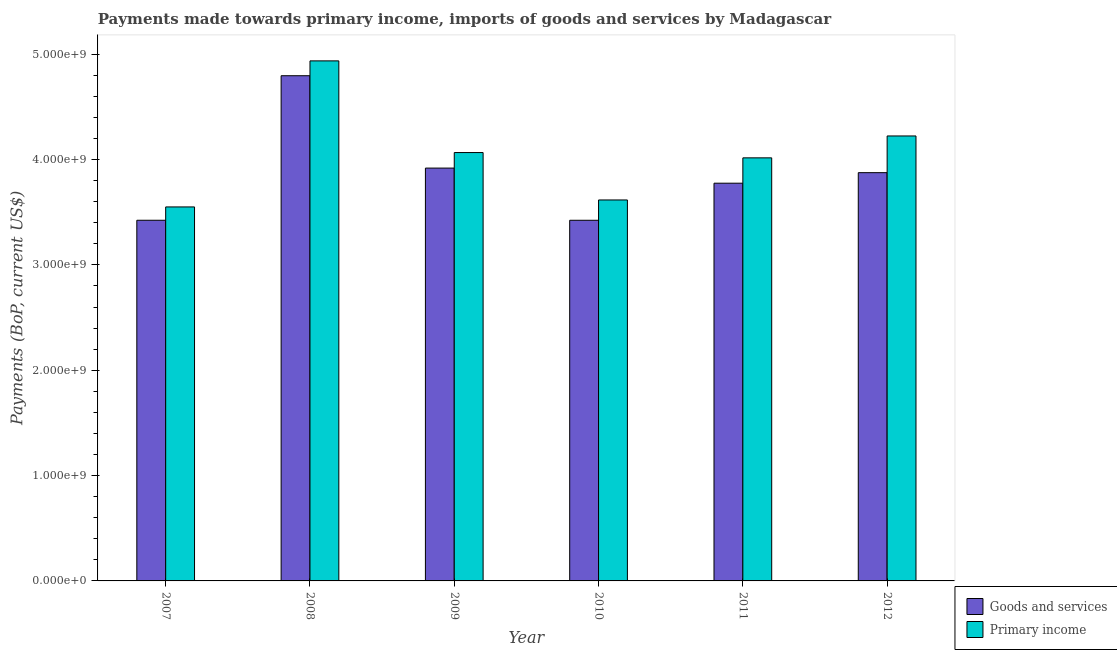How many different coloured bars are there?
Make the answer very short. 2. Are the number of bars per tick equal to the number of legend labels?
Keep it short and to the point. Yes. How many bars are there on the 5th tick from the left?
Offer a terse response. 2. What is the label of the 4th group of bars from the left?
Keep it short and to the point. 2010. In how many cases, is the number of bars for a given year not equal to the number of legend labels?
Make the answer very short. 0. What is the payments made towards primary income in 2011?
Make the answer very short. 4.02e+09. Across all years, what is the maximum payments made towards primary income?
Provide a succinct answer. 4.94e+09. Across all years, what is the minimum payments made towards primary income?
Make the answer very short. 3.55e+09. In which year was the payments made towards goods and services maximum?
Your answer should be very brief. 2008. In which year was the payments made towards primary income minimum?
Your answer should be compact. 2007. What is the total payments made towards primary income in the graph?
Ensure brevity in your answer.  2.44e+1. What is the difference between the payments made towards goods and services in 2007 and that in 2009?
Offer a very short reply. -4.95e+08. What is the difference between the payments made towards goods and services in 2009 and the payments made towards primary income in 2010?
Provide a succinct answer. 4.95e+08. What is the average payments made towards goods and services per year?
Offer a terse response. 3.87e+09. In the year 2011, what is the difference between the payments made towards primary income and payments made towards goods and services?
Your response must be concise. 0. What is the ratio of the payments made towards goods and services in 2009 to that in 2011?
Provide a succinct answer. 1.04. Is the payments made towards primary income in 2008 less than that in 2012?
Your answer should be compact. No. What is the difference between the highest and the second highest payments made towards primary income?
Make the answer very short. 7.13e+08. What is the difference between the highest and the lowest payments made towards goods and services?
Make the answer very short. 1.37e+09. In how many years, is the payments made towards primary income greater than the average payments made towards primary income taken over all years?
Give a very brief answer. 2. Is the sum of the payments made towards goods and services in 2007 and 2011 greater than the maximum payments made towards primary income across all years?
Ensure brevity in your answer.  Yes. What does the 2nd bar from the left in 2012 represents?
Provide a short and direct response. Primary income. What does the 2nd bar from the right in 2007 represents?
Ensure brevity in your answer.  Goods and services. How many bars are there?
Offer a terse response. 12. Are all the bars in the graph horizontal?
Offer a very short reply. No. Does the graph contain any zero values?
Make the answer very short. No. How are the legend labels stacked?
Provide a succinct answer. Vertical. What is the title of the graph?
Ensure brevity in your answer.  Payments made towards primary income, imports of goods and services by Madagascar. Does "Canada" appear as one of the legend labels in the graph?
Offer a very short reply. No. What is the label or title of the X-axis?
Offer a terse response. Year. What is the label or title of the Y-axis?
Your answer should be very brief. Payments (BoP, current US$). What is the Payments (BoP, current US$) of Goods and services in 2007?
Keep it short and to the point. 3.42e+09. What is the Payments (BoP, current US$) of Primary income in 2007?
Ensure brevity in your answer.  3.55e+09. What is the Payments (BoP, current US$) of Goods and services in 2008?
Offer a terse response. 4.80e+09. What is the Payments (BoP, current US$) of Primary income in 2008?
Ensure brevity in your answer.  4.94e+09. What is the Payments (BoP, current US$) in Goods and services in 2009?
Keep it short and to the point. 3.92e+09. What is the Payments (BoP, current US$) of Primary income in 2009?
Give a very brief answer. 4.07e+09. What is the Payments (BoP, current US$) of Goods and services in 2010?
Your answer should be compact. 3.42e+09. What is the Payments (BoP, current US$) of Primary income in 2010?
Offer a very short reply. 3.62e+09. What is the Payments (BoP, current US$) of Goods and services in 2011?
Provide a short and direct response. 3.78e+09. What is the Payments (BoP, current US$) of Primary income in 2011?
Make the answer very short. 4.02e+09. What is the Payments (BoP, current US$) in Goods and services in 2012?
Give a very brief answer. 3.88e+09. What is the Payments (BoP, current US$) in Primary income in 2012?
Give a very brief answer. 4.22e+09. Across all years, what is the maximum Payments (BoP, current US$) in Goods and services?
Give a very brief answer. 4.80e+09. Across all years, what is the maximum Payments (BoP, current US$) of Primary income?
Ensure brevity in your answer.  4.94e+09. Across all years, what is the minimum Payments (BoP, current US$) of Goods and services?
Keep it short and to the point. 3.42e+09. Across all years, what is the minimum Payments (BoP, current US$) of Primary income?
Provide a short and direct response. 3.55e+09. What is the total Payments (BoP, current US$) of Goods and services in the graph?
Ensure brevity in your answer.  2.32e+1. What is the total Payments (BoP, current US$) of Primary income in the graph?
Your response must be concise. 2.44e+1. What is the difference between the Payments (BoP, current US$) of Goods and services in 2007 and that in 2008?
Keep it short and to the point. -1.37e+09. What is the difference between the Payments (BoP, current US$) of Primary income in 2007 and that in 2008?
Your response must be concise. -1.39e+09. What is the difference between the Payments (BoP, current US$) of Goods and services in 2007 and that in 2009?
Give a very brief answer. -4.95e+08. What is the difference between the Payments (BoP, current US$) of Primary income in 2007 and that in 2009?
Provide a short and direct response. -5.16e+08. What is the difference between the Payments (BoP, current US$) of Goods and services in 2007 and that in 2010?
Your answer should be very brief. 1.95e+05. What is the difference between the Payments (BoP, current US$) in Primary income in 2007 and that in 2010?
Ensure brevity in your answer.  -6.61e+07. What is the difference between the Payments (BoP, current US$) of Goods and services in 2007 and that in 2011?
Provide a succinct answer. -3.52e+08. What is the difference between the Payments (BoP, current US$) of Primary income in 2007 and that in 2011?
Provide a succinct answer. -4.66e+08. What is the difference between the Payments (BoP, current US$) of Goods and services in 2007 and that in 2012?
Provide a succinct answer. -4.52e+08. What is the difference between the Payments (BoP, current US$) in Primary income in 2007 and that in 2012?
Your answer should be very brief. -6.74e+08. What is the difference between the Payments (BoP, current US$) of Goods and services in 2008 and that in 2009?
Your response must be concise. 8.77e+08. What is the difference between the Payments (BoP, current US$) of Primary income in 2008 and that in 2009?
Ensure brevity in your answer.  8.70e+08. What is the difference between the Payments (BoP, current US$) in Goods and services in 2008 and that in 2010?
Your response must be concise. 1.37e+09. What is the difference between the Payments (BoP, current US$) in Primary income in 2008 and that in 2010?
Offer a very short reply. 1.32e+09. What is the difference between the Payments (BoP, current US$) of Goods and services in 2008 and that in 2011?
Give a very brief answer. 1.02e+09. What is the difference between the Payments (BoP, current US$) of Primary income in 2008 and that in 2011?
Offer a very short reply. 9.20e+08. What is the difference between the Payments (BoP, current US$) in Goods and services in 2008 and that in 2012?
Your response must be concise. 9.20e+08. What is the difference between the Payments (BoP, current US$) of Primary income in 2008 and that in 2012?
Offer a very short reply. 7.13e+08. What is the difference between the Payments (BoP, current US$) in Goods and services in 2009 and that in 2010?
Your response must be concise. 4.95e+08. What is the difference between the Payments (BoP, current US$) of Primary income in 2009 and that in 2010?
Offer a terse response. 4.50e+08. What is the difference between the Payments (BoP, current US$) in Goods and services in 2009 and that in 2011?
Your answer should be very brief. 1.43e+08. What is the difference between the Payments (BoP, current US$) of Primary income in 2009 and that in 2011?
Keep it short and to the point. 5.02e+07. What is the difference between the Payments (BoP, current US$) of Goods and services in 2009 and that in 2012?
Offer a terse response. 4.34e+07. What is the difference between the Payments (BoP, current US$) in Primary income in 2009 and that in 2012?
Your answer should be very brief. -1.58e+08. What is the difference between the Payments (BoP, current US$) of Goods and services in 2010 and that in 2011?
Give a very brief answer. -3.52e+08. What is the difference between the Payments (BoP, current US$) in Primary income in 2010 and that in 2011?
Your response must be concise. -4.00e+08. What is the difference between the Payments (BoP, current US$) in Goods and services in 2010 and that in 2012?
Ensure brevity in your answer.  -4.52e+08. What is the difference between the Payments (BoP, current US$) in Primary income in 2010 and that in 2012?
Make the answer very short. -6.08e+08. What is the difference between the Payments (BoP, current US$) in Goods and services in 2011 and that in 2012?
Make the answer very short. -1.00e+08. What is the difference between the Payments (BoP, current US$) in Primary income in 2011 and that in 2012?
Offer a terse response. -2.08e+08. What is the difference between the Payments (BoP, current US$) of Goods and services in 2007 and the Payments (BoP, current US$) of Primary income in 2008?
Your answer should be compact. -1.51e+09. What is the difference between the Payments (BoP, current US$) of Goods and services in 2007 and the Payments (BoP, current US$) of Primary income in 2009?
Provide a short and direct response. -6.43e+08. What is the difference between the Payments (BoP, current US$) of Goods and services in 2007 and the Payments (BoP, current US$) of Primary income in 2010?
Keep it short and to the point. -1.93e+08. What is the difference between the Payments (BoP, current US$) of Goods and services in 2007 and the Payments (BoP, current US$) of Primary income in 2011?
Provide a short and direct response. -5.92e+08. What is the difference between the Payments (BoP, current US$) in Goods and services in 2007 and the Payments (BoP, current US$) in Primary income in 2012?
Provide a succinct answer. -8.00e+08. What is the difference between the Payments (BoP, current US$) of Goods and services in 2008 and the Payments (BoP, current US$) of Primary income in 2009?
Your answer should be very brief. 7.29e+08. What is the difference between the Payments (BoP, current US$) in Goods and services in 2008 and the Payments (BoP, current US$) in Primary income in 2010?
Make the answer very short. 1.18e+09. What is the difference between the Payments (BoP, current US$) in Goods and services in 2008 and the Payments (BoP, current US$) in Primary income in 2011?
Provide a short and direct response. 7.79e+08. What is the difference between the Payments (BoP, current US$) in Goods and services in 2008 and the Payments (BoP, current US$) in Primary income in 2012?
Offer a very short reply. 5.72e+08. What is the difference between the Payments (BoP, current US$) in Goods and services in 2009 and the Payments (BoP, current US$) in Primary income in 2010?
Your response must be concise. 3.03e+08. What is the difference between the Payments (BoP, current US$) of Goods and services in 2009 and the Payments (BoP, current US$) of Primary income in 2011?
Ensure brevity in your answer.  -9.72e+07. What is the difference between the Payments (BoP, current US$) in Goods and services in 2009 and the Payments (BoP, current US$) in Primary income in 2012?
Your response must be concise. -3.05e+08. What is the difference between the Payments (BoP, current US$) of Goods and services in 2010 and the Payments (BoP, current US$) of Primary income in 2011?
Make the answer very short. -5.92e+08. What is the difference between the Payments (BoP, current US$) in Goods and services in 2010 and the Payments (BoP, current US$) in Primary income in 2012?
Provide a succinct answer. -8.00e+08. What is the difference between the Payments (BoP, current US$) of Goods and services in 2011 and the Payments (BoP, current US$) of Primary income in 2012?
Provide a succinct answer. -4.48e+08. What is the average Payments (BoP, current US$) in Goods and services per year?
Provide a short and direct response. 3.87e+09. What is the average Payments (BoP, current US$) of Primary income per year?
Offer a very short reply. 4.07e+09. In the year 2007, what is the difference between the Payments (BoP, current US$) in Goods and services and Payments (BoP, current US$) in Primary income?
Provide a succinct answer. -1.26e+08. In the year 2008, what is the difference between the Payments (BoP, current US$) in Goods and services and Payments (BoP, current US$) in Primary income?
Offer a very short reply. -1.41e+08. In the year 2009, what is the difference between the Payments (BoP, current US$) in Goods and services and Payments (BoP, current US$) in Primary income?
Ensure brevity in your answer.  -1.47e+08. In the year 2010, what is the difference between the Payments (BoP, current US$) in Goods and services and Payments (BoP, current US$) in Primary income?
Provide a succinct answer. -1.93e+08. In the year 2011, what is the difference between the Payments (BoP, current US$) in Goods and services and Payments (BoP, current US$) in Primary income?
Provide a short and direct response. -2.41e+08. In the year 2012, what is the difference between the Payments (BoP, current US$) of Goods and services and Payments (BoP, current US$) of Primary income?
Keep it short and to the point. -3.48e+08. What is the ratio of the Payments (BoP, current US$) of Goods and services in 2007 to that in 2008?
Your answer should be very brief. 0.71. What is the ratio of the Payments (BoP, current US$) of Primary income in 2007 to that in 2008?
Your answer should be compact. 0.72. What is the ratio of the Payments (BoP, current US$) in Goods and services in 2007 to that in 2009?
Offer a terse response. 0.87. What is the ratio of the Payments (BoP, current US$) of Primary income in 2007 to that in 2009?
Provide a short and direct response. 0.87. What is the ratio of the Payments (BoP, current US$) in Primary income in 2007 to that in 2010?
Ensure brevity in your answer.  0.98. What is the ratio of the Payments (BoP, current US$) of Goods and services in 2007 to that in 2011?
Give a very brief answer. 0.91. What is the ratio of the Payments (BoP, current US$) of Primary income in 2007 to that in 2011?
Your answer should be very brief. 0.88. What is the ratio of the Payments (BoP, current US$) in Goods and services in 2007 to that in 2012?
Give a very brief answer. 0.88. What is the ratio of the Payments (BoP, current US$) in Primary income in 2007 to that in 2012?
Your answer should be compact. 0.84. What is the ratio of the Payments (BoP, current US$) in Goods and services in 2008 to that in 2009?
Give a very brief answer. 1.22. What is the ratio of the Payments (BoP, current US$) in Primary income in 2008 to that in 2009?
Provide a succinct answer. 1.21. What is the ratio of the Payments (BoP, current US$) of Goods and services in 2008 to that in 2010?
Your response must be concise. 1.4. What is the ratio of the Payments (BoP, current US$) of Primary income in 2008 to that in 2010?
Your response must be concise. 1.37. What is the ratio of the Payments (BoP, current US$) in Goods and services in 2008 to that in 2011?
Offer a very short reply. 1.27. What is the ratio of the Payments (BoP, current US$) of Primary income in 2008 to that in 2011?
Offer a very short reply. 1.23. What is the ratio of the Payments (BoP, current US$) in Goods and services in 2008 to that in 2012?
Give a very brief answer. 1.24. What is the ratio of the Payments (BoP, current US$) of Primary income in 2008 to that in 2012?
Provide a short and direct response. 1.17. What is the ratio of the Payments (BoP, current US$) of Goods and services in 2009 to that in 2010?
Keep it short and to the point. 1.14. What is the ratio of the Payments (BoP, current US$) of Primary income in 2009 to that in 2010?
Your answer should be very brief. 1.12. What is the ratio of the Payments (BoP, current US$) in Goods and services in 2009 to that in 2011?
Make the answer very short. 1.04. What is the ratio of the Payments (BoP, current US$) in Primary income in 2009 to that in 2011?
Your response must be concise. 1.01. What is the ratio of the Payments (BoP, current US$) in Goods and services in 2009 to that in 2012?
Your answer should be compact. 1.01. What is the ratio of the Payments (BoP, current US$) in Primary income in 2009 to that in 2012?
Ensure brevity in your answer.  0.96. What is the ratio of the Payments (BoP, current US$) in Goods and services in 2010 to that in 2011?
Your answer should be compact. 0.91. What is the ratio of the Payments (BoP, current US$) of Primary income in 2010 to that in 2011?
Your response must be concise. 0.9. What is the ratio of the Payments (BoP, current US$) in Goods and services in 2010 to that in 2012?
Your answer should be compact. 0.88. What is the ratio of the Payments (BoP, current US$) of Primary income in 2010 to that in 2012?
Your answer should be compact. 0.86. What is the ratio of the Payments (BoP, current US$) in Goods and services in 2011 to that in 2012?
Offer a terse response. 0.97. What is the ratio of the Payments (BoP, current US$) of Primary income in 2011 to that in 2012?
Give a very brief answer. 0.95. What is the difference between the highest and the second highest Payments (BoP, current US$) in Goods and services?
Your answer should be very brief. 8.77e+08. What is the difference between the highest and the second highest Payments (BoP, current US$) in Primary income?
Make the answer very short. 7.13e+08. What is the difference between the highest and the lowest Payments (BoP, current US$) of Goods and services?
Ensure brevity in your answer.  1.37e+09. What is the difference between the highest and the lowest Payments (BoP, current US$) in Primary income?
Make the answer very short. 1.39e+09. 